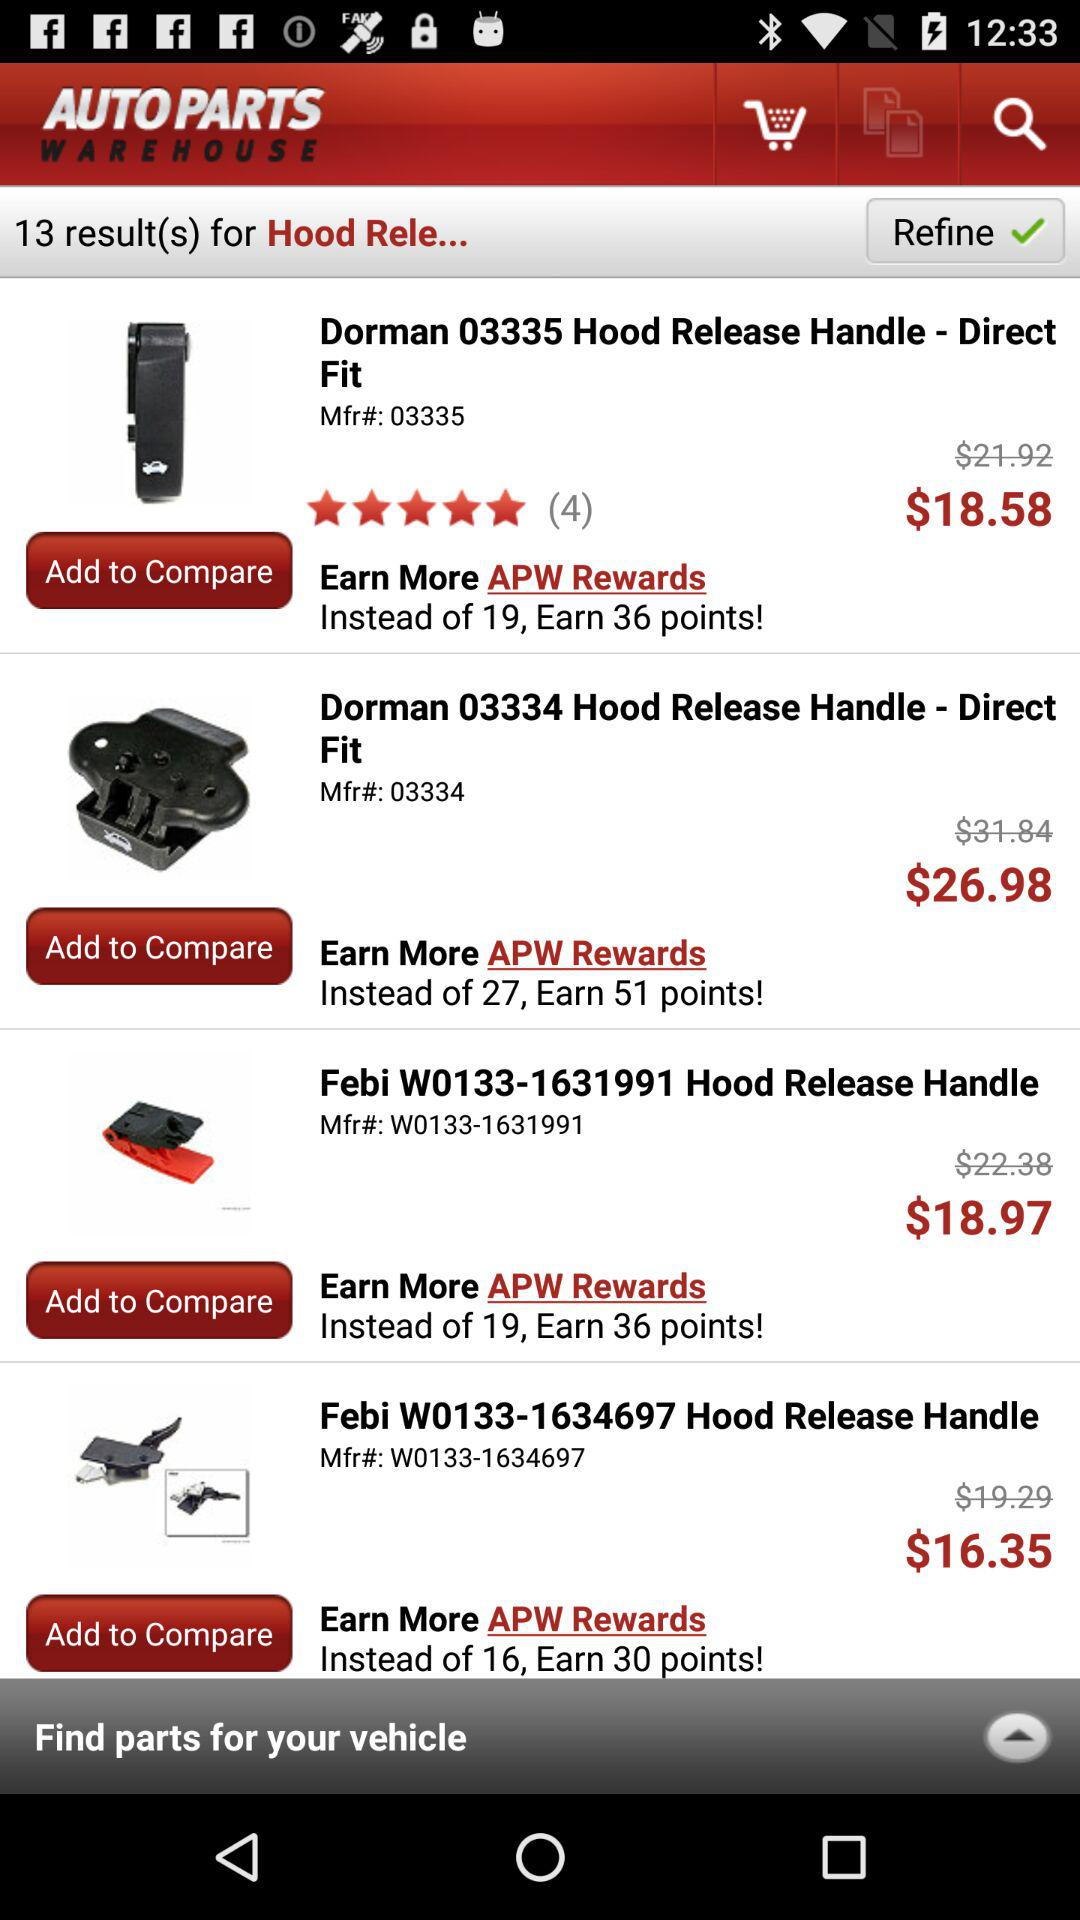How many points can be earned on "Febi W0133-1634697"? The number of points that can be earned is 30. 